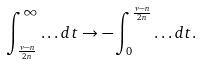<formula> <loc_0><loc_0><loc_500><loc_500>\int _ { \frac { \nu - n } { 2 n } } ^ { \infty } \dots d t \rightarrow - \int _ { 0 } ^ { \frac { \nu - n } { 2 n } } \dots d t .</formula> 